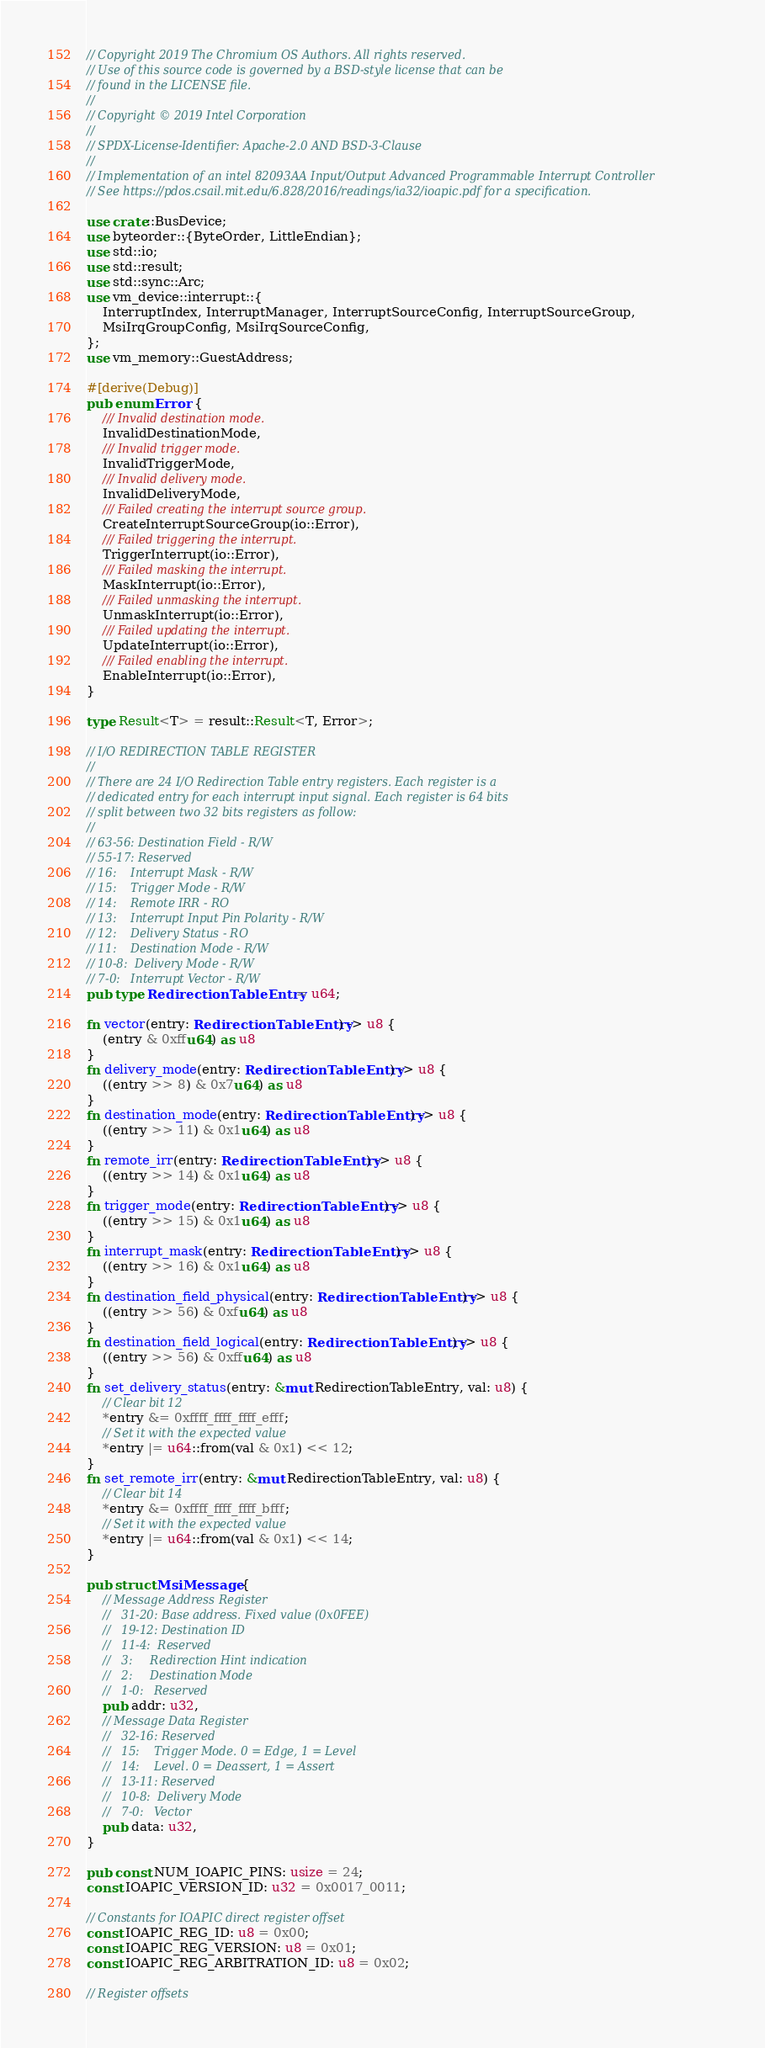<code> <loc_0><loc_0><loc_500><loc_500><_Rust_>// Copyright 2019 The Chromium OS Authors. All rights reserved.
// Use of this source code is governed by a BSD-style license that can be
// found in the LICENSE file.
//
// Copyright © 2019 Intel Corporation
//
// SPDX-License-Identifier: Apache-2.0 AND BSD-3-Clause
//
// Implementation of an intel 82093AA Input/Output Advanced Programmable Interrupt Controller
// See https://pdos.csail.mit.edu/6.828/2016/readings/ia32/ioapic.pdf for a specification.

use crate::BusDevice;
use byteorder::{ByteOrder, LittleEndian};
use std::io;
use std::result;
use std::sync::Arc;
use vm_device::interrupt::{
    InterruptIndex, InterruptManager, InterruptSourceConfig, InterruptSourceGroup,
    MsiIrqGroupConfig, MsiIrqSourceConfig,
};
use vm_memory::GuestAddress;

#[derive(Debug)]
pub enum Error {
    /// Invalid destination mode.
    InvalidDestinationMode,
    /// Invalid trigger mode.
    InvalidTriggerMode,
    /// Invalid delivery mode.
    InvalidDeliveryMode,
    /// Failed creating the interrupt source group.
    CreateInterruptSourceGroup(io::Error),
    /// Failed triggering the interrupt.
    TriggerInterrupt(io::Error),
    /// Failed masking the interrupt.
    MaskInterrupt(io::Error),
    /// Failed unmasking the interrupt.
    UnmaskInterrupt(io::Error),
    /// Failed updating the interrupt.
    UpdateInterrupt(io::Error),
    /// Failed enabling the interrupt.
    EnableInterrupt(io::Error),
}

type Result<T> = result::Result<T, Error>;

// I/O REDIRECTION TABLE REGISTER
//
// There are 24 I/O Redirection Table entry registers. Each register is a
// dedicated entry for each interrupt input signal. Each register is 64 bits
// split between two 32 bits registers as follow:
//
// 63-56: Destination Field - R/W
// 55-17: Reserved
// 16:    Interrupt Mask - R/W
// 15:    Trigger Mode - R/W
// 14:    Remote IRR - RO
// 13:    Interrupt Input Pin Polarity - R/W
// 12:    Delivery Status - RO
// 11:    Destination Mode - R/W
// 10-8:  Delivery Mode - R/W
// 7-0:   Interrupt Vector - R/W
pub type RedirectionTableEntry = u64;

fn vector(entry: RedirectionTableEntry) -> u8 {
    (entry & 0xffu64) as u8
}
fn delivery_mode(entry: RedirectionTableEntry) -> u8 {
    ((entry >> 8) & 0x7u64) as u8
}
fn destination_mode(entry: RedirectionTableEntry) -> u8 {
    ((entry >> 11) & 0x1u64) as u8
}
fn remote_irr(entry: RedirectionTableEntry) -> u8 {
    ((entry >> 14) & 0x1u64) as u8
}
fn trigger_mode(entry: RedirectionTableEntry) -> u8 {
    ((entry >> 15) & 0x1u64) as u8
}
fn interrupt_mask(entry: RedirectionTableEntry) -> u8 {
    ((entry >> 16) & 0x1u64) as u8
}
fn destination_field_physical(entry: RedirectionTableEntry) -> u8 {
    ((entry >> 56) & 0xfu64) as u8
}
fn destination_field_logical(entry: RedirectionTableEntry) -> u8 {
    ((entry >> 56) & 0xffu64) as u8
}
fn set_delivery_status(entry: &mut RedirectionTableEntry, val: u8) {
    // Clear bit 12
    *entry &= 0xffff_ffff_ffff_efff;
    // Set it with the expected value
    *entry |= u64::from(val & 0x1) << 12;
}
fn set_remote_irr(entry: &mut RedirectionTableEntry, val: u8) {
    // Clear bit 14
    *entry &= 0xffff_ffff_ffff_bfff;
    // Set it with the expected value
    *entry |= u64::from(val & 0x1) << 14;
}

pub struct MsiMessage {
    // Message Address Register
    //   31-20: Base address. Fixed value (0x0FEE)
    //   19-12: Destination ID
    //   11-4:  Reserved
    //   3:     Redirection Hint indication
    //   2:     Destination Mode
    //   1-0:   Reserved
    pub addr: u32,
    // Message Data Register
    //   32-16: Reserved
    //   15:    Trigger Mode. 0 = Edge, 1 = Level
    //   14:    Level. 0 = Deassert, 1 = Assert
    //   13-11: Reserved
    //   10-8:  Delivery Mode
    //   7-0:   Vector
    pub data: u32,
}

pub const NUM_IOAPIC_PINS: usize = 24;
const IOAPIC_VERSION_ID: u32 = 0x0017_0011;

// Constants for IOAPIC direct register offset
const IOAPIC_REG_ID: u8 = 0x00;
const IOAPIC_REG_VERSION: u8 = 0x01;
const IOAPIC_REG_ARBITRATION_ID: u8 = 0x02;

// Register offsets</code> 